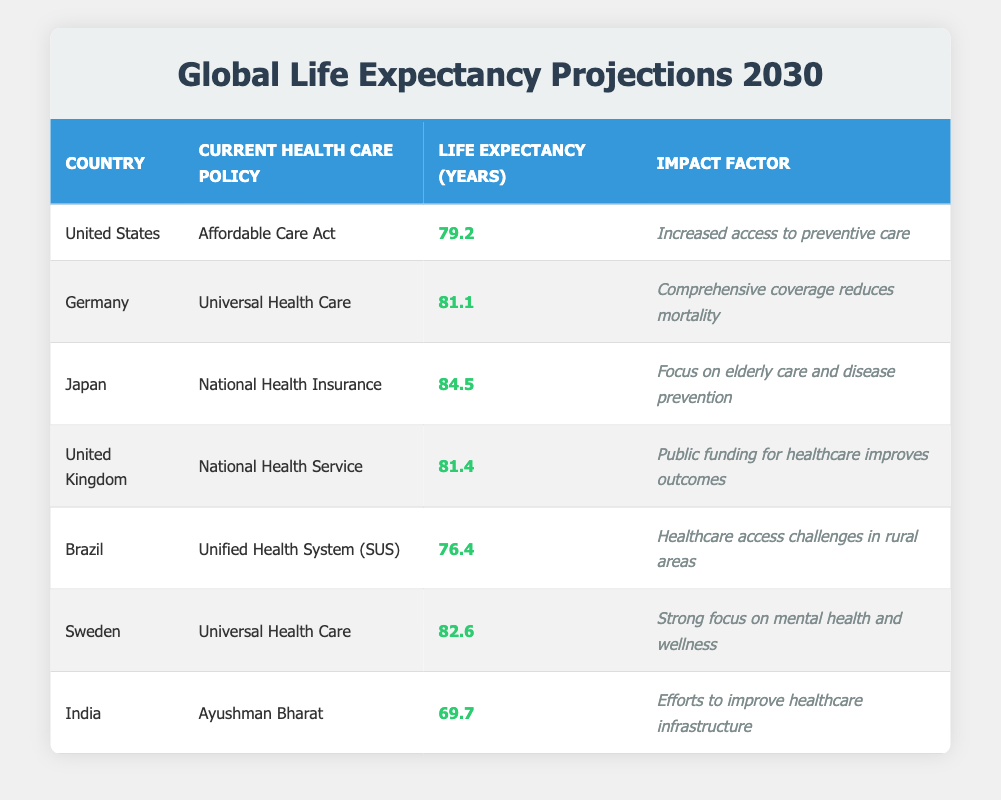What is the life expectancy for Japan based on the table? According to the table, Japan has a life expectancy of 84.5 years. This value is found directly in the row corresponding to Japan.
Answer: 84.5 Which country has the highest life expectancy projection in 2030? By examining each country's life expectancy values in the table, Japan has the highest projected life expectancy at 84.5 years.
Answer: Japan What impact factor is associated with Germany's current health care policy? The impact factor listed under Germany's current health care policy, which is Universal Health Care, is "Comprehensive coverage reduces mortality." This can be found in the respective row of the table.
Answer: Comprehensive coverage reduces mortality How does the life expectancy in the United States compare to that in India? The life expectancy in the United States is 79.2 years while in India, it is 69.7 years. To compare, subtract India's life expectancy from that of the U.S. (79.2 - 69.7 = 9.5). Therefore, the U.S. has a higher life expectancy by 9.5 years.
Answer: United States has a higher life expectancy by 9.5 years Is the life expectancy in Brazil higher than 80 years based on the data? The life expectancy in Brazil is 76.4 years, which is less than 80 years. Thus, the statement is false based on the data provided in the table.
Answer: No What is the average life expectancy of the countries listed in the table? To calculate the average, first sum all the life expectancy values: 79.2 + 81.1 + 84.5 + 81.4 + 76.4 + 82.6 + 69.7 = 465.9. Then divide by the number of countries (7): 465.9 / 7 ≈ 66.7. Hence, the average life expectancy is approximately 76.57 years.
Answer: 76.57 Which country has the lowest life expectancy and what is that value? By reviewing the life expectancy values, India has the lowest at 69.7 years according to the table. This is confirmed by identifying the smallest value in the life expectancy column.
Answer: India, 69.7 What health care policy does Sweden utilize, and what is its associated impact factor? Sweden utilizes Universal Health Care, and it has the impact factor of "Strong focus on mental health and wellness" as indicated in the corresponding row of the table.
Answer: Universal Health Care; Strong focus on mental health and wellness 